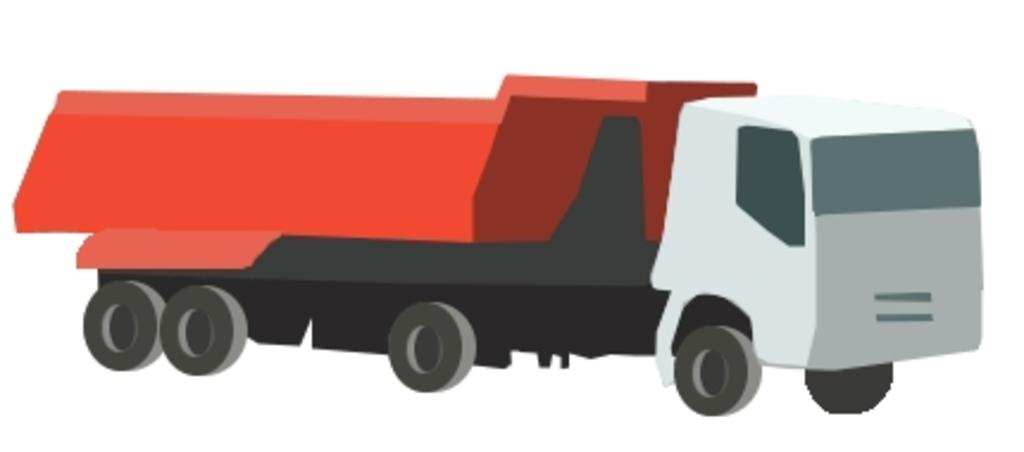What is the main subject of the image? There is a depiction of a truck in the image. What type of ring is the truck wearing in the image? There is no ring present in the image, as it features a depiction of a truck. How much tax is the truck paying in the image? There is no mention of tax in the image, as it features a depiction of a truck. 